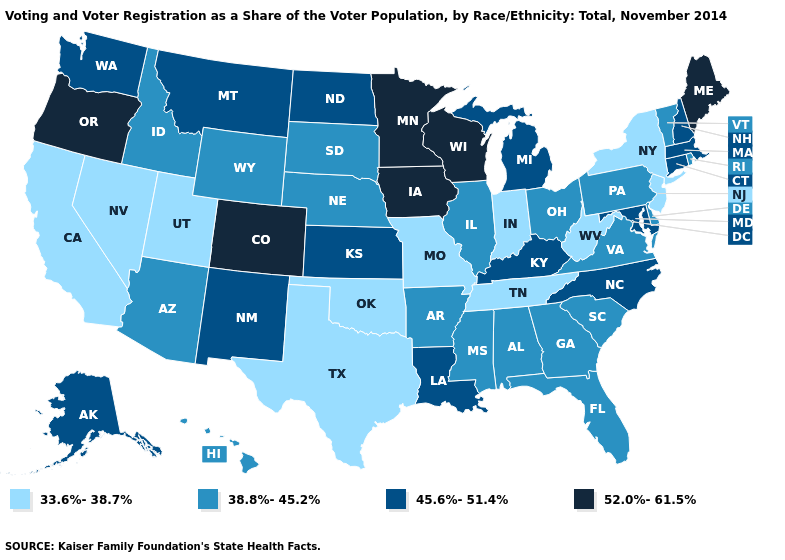Which states hav the highest value in the South?
Keep it brief. Kentucky, Louisiana, Maryland, North Carolina. Among the states that border West Virginia , which have the lowest value?
Write a very short answer. Ohio, Pennsylvania, Virginia. Name the states that have a value in the range 45.6%-51.4%?
Write a very short answer. Alaska, Connecticut, Kansas, Kentucky, Louisiana, Maryland, Massachusetts, Michigan, Montana, New Hampshire, New Mexico, North Carolina, North Dakota, Washington. Name the states that have a value in the range 33.6%-38.7%?
Concise answer only. California, Indiana, Missouri, Nevada, New Jersey, New York, Oklahoma, Tennessee, Texas, Utah, West Virginia. Does South Dakota have a higher value than Oklahoma?
Short answer required. Yes. Name the states that have a value in the range 38.8%-45.2%?
Keep it brief. Alabama, Arizona, Arkansas, Delaware, Florida, Georgia, Hawaii, Idaho, Illinois, Mississippi, Nebraska, Ohio, Pennsylvania, Rhode Island, South Carolina, South Dakota, Vermont, Virginia, Wyoming. What is the lowest value in the South?
Quick response, please. 33.6%-38.7%. What is the value of Arkansas?
Quick response, please. 38.8%-45.2%. Does Missouri have the lowest value in the USA?
Concise answer only. Yes. What is the value of Missouri?
Write a very short answer. 33.6%-38.7%. Does the map have missing data?
Short answer required. No. Does the map have missing data?
Answer briefly. No. Name the states that have a value in the range 45.6%-51.4%?
Write a very short answer. Alaska, Connecticut, Kansas, Kentucky, Louisiana, Maryland, Massachusetts, Michigan, Montana, New Hampshire, New Mexico, North Carolina, North Dakota, Washington. Does Maine have the highest value in the USA?
Be succinct. Yes. 